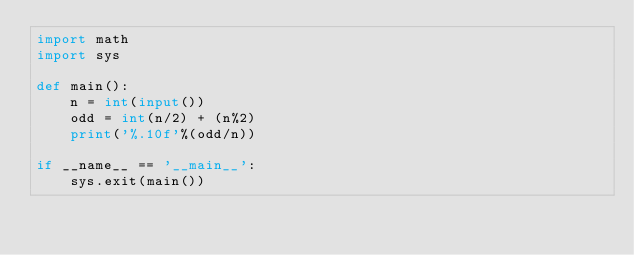<code> <loc_0><loc_0><loc_500><loc_500><_Python_>import math
import sys

def main():
    n = int(input())
    odd = int(n/2) + (n%2)
    print('%.10f'%(odd/n))

if __name__ == '__main__':
    sys.exit(main())</code> 